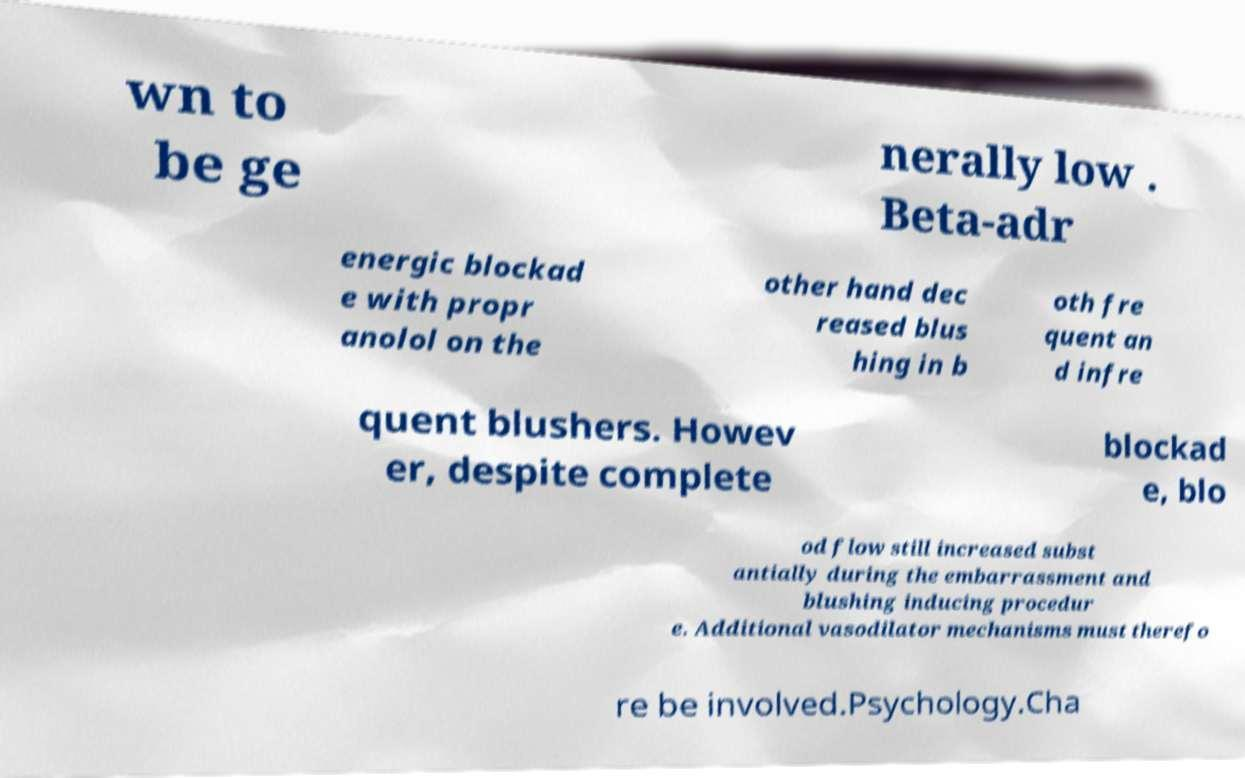For documentation purposes, I need the text within this image transcribed. Could you provide that? wn to be ge nerally low . Beta-adr energic blockad e with propr anolol on the other hand dec reased blus hing in b oth fre quent an d infre quent blushers. Howev er, despite complete blockad e, blo od flow still increased subst antially during the embarrassment and blushing inducing procedur e. Additional vasodilator mechanisms must therefo re be involved.Psychology.Cha 